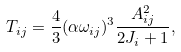<formula> <loc_0><loc_0><loc_500><loc_500>T _ { i j } = \frac { 4 } { 3 } ( \alpha \omega _ { i j } ) ^ { 3 } \frac { A _ { i j } ^ { 2 } } { 2 J _ { i } + 1 } ,</formula> 